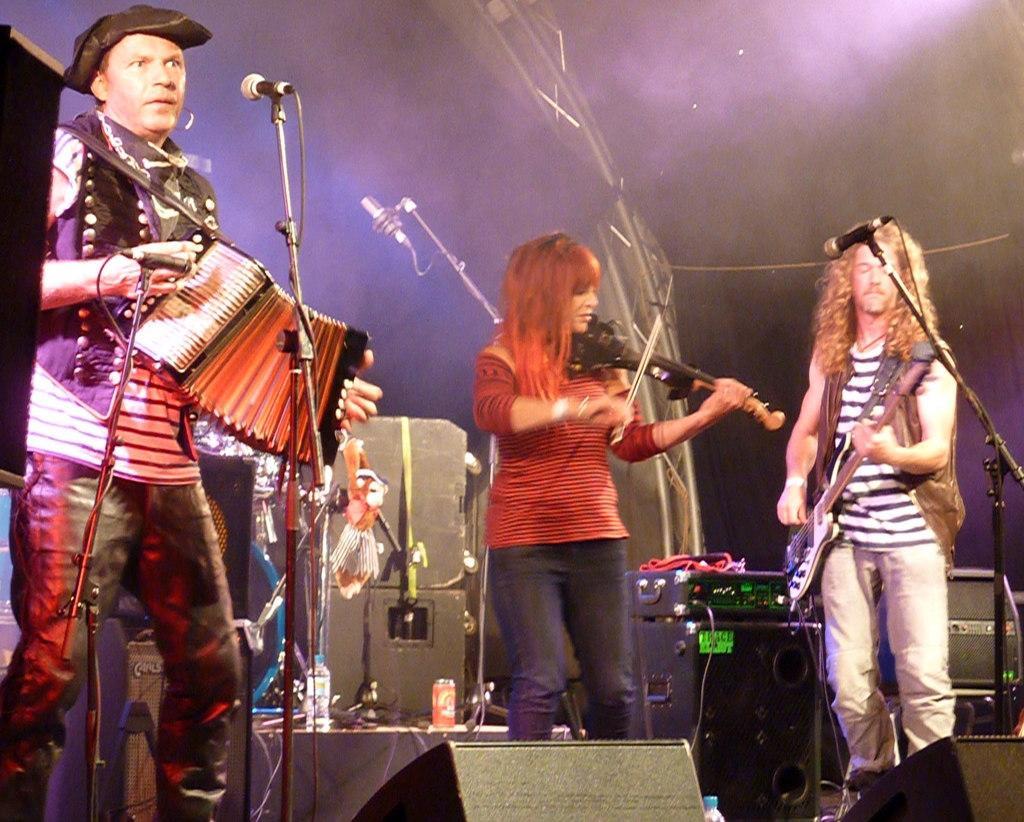Could you give a brief overview of what you see in this image? In the center of the image we can see three persons are standing and they are in different costumes and they are holding some musical instruments. On the left side of the image, we can see an object. In front of them, we can see stands and microphones. In the background, we can see a water bottle, few musical instruments and a few other objects. 